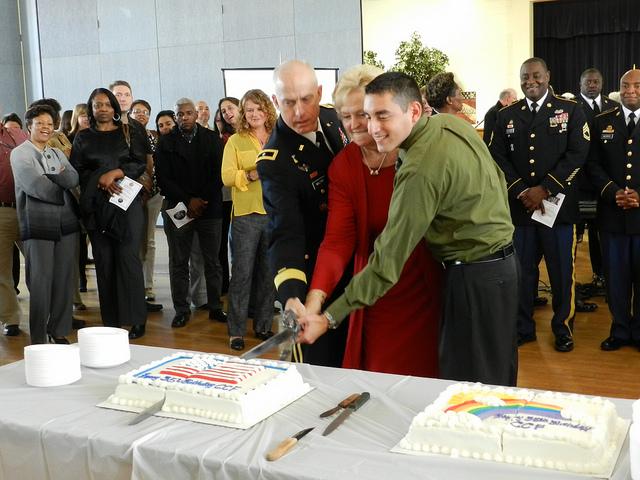What is the man cutting the cake wearing?
Answer briefly. Military uniform. How many sheet cakes are shown?
Short answer required. 2. What color is the man's tie?
Short answer required. Black. Can these cakes feed all these people?
Concise answer only. Yes. Is this a military gathering?
Quick response, please. Yes. 